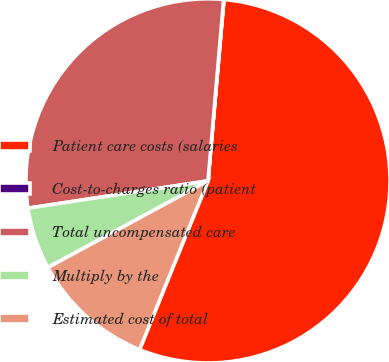Convert chart to OTSL. <chart><loc_0><loc_0><loc_500><loc_500><pie_chart><fcel>Patient care costs (salaries<fcel>Cost-to-charges ratio (patient<fcel>Total uncompensated care<fcel>Multiply by the<fcel>Estimated cost of total<nl><fcel>54.73%<fcel>0.03%<fcel>28.77%<fcel>5.5%<fcel>10.97%<nl></chart> 